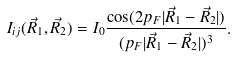<formula> <loc_0><loc_0><loc_500><loc_500>I _ { i j } ( \vec { R } _ { 1 } , \vec { R } _ { 2 } ) = I _ { 0 } \frac { \cos ( 2 p _ { F } | \vec { R } _ { 1 } - \vec { R } _ { 2 } | ) } { ( p _ { F } | \vec { R } _ { 1 } - \vec { R } _ { 2 } | ) ^ { 3 } } .</formula> 